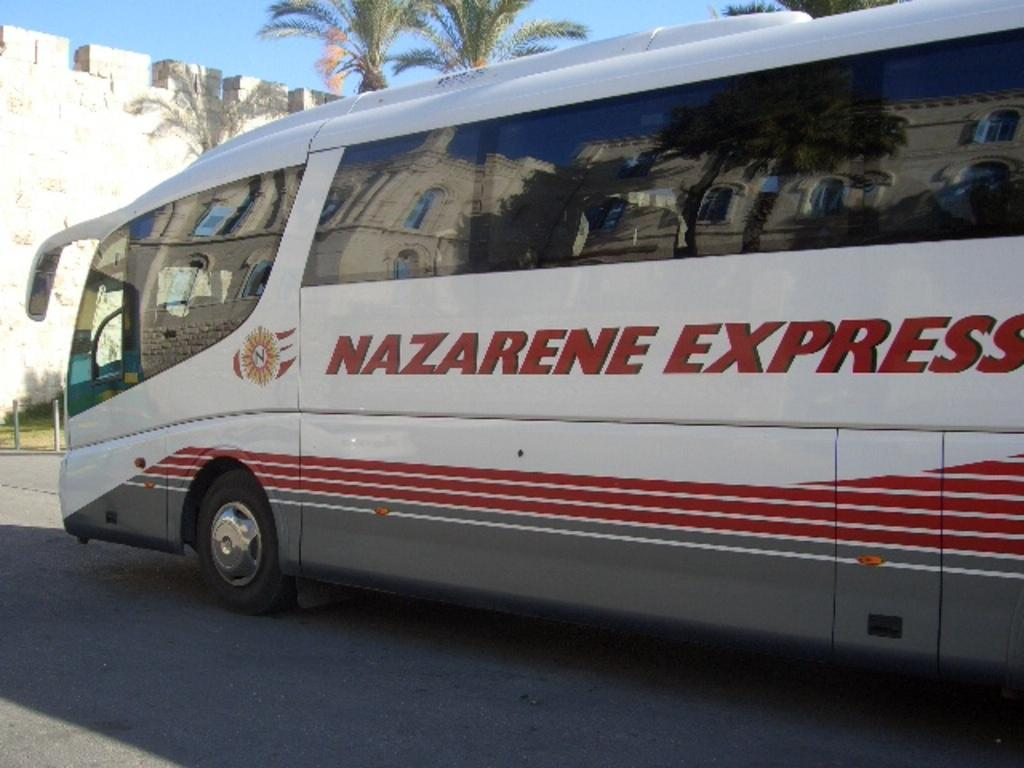<image>
Share a concise interpretation of the image provided. A bus is labeled with Nazarene Express on its side. 